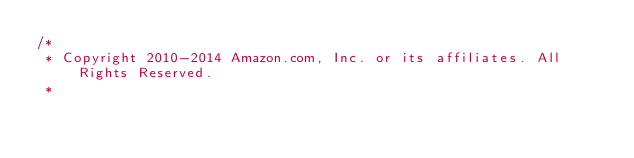Convert code to text. <code><loc_0><loc_0><loc_500><loc_500><_C#_>/*
 * Copyright 2010-2014 Amazon.com, Inc. or its affiliates. All Rights Reserved.
 * </code> 